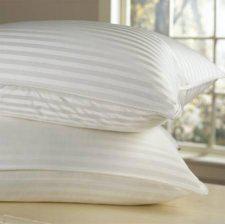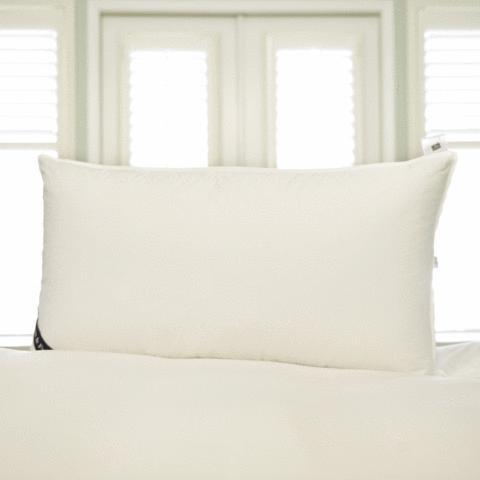The first image is the image on the left, the second image is the image on the right. Assess this claim about the two images: "There is only one pillow in one of the images.". Correct or not? Answer yes or no. Yes. The first image is the image on the left, the second image is the image on the right. For the images shown, is this caption "There are three pillows in the pair of images." true? Answer yes or no. Yes. 